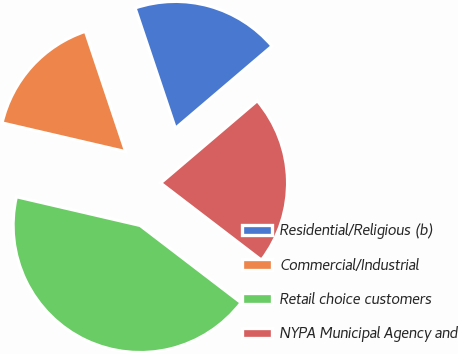Convert chart. <chart><loc_0><loc_0><loc_500><loc_500><pie_chart><fcel>Residential/Religious (b)<fcel>Commercial/Industrial<fcel>Retail choice customers<fcel>NYPA Municipal Agency and<nl><fcel>18.92%<fcel>16.22%<fcel>43.24%<fcel>21.62%<nl></chart> 